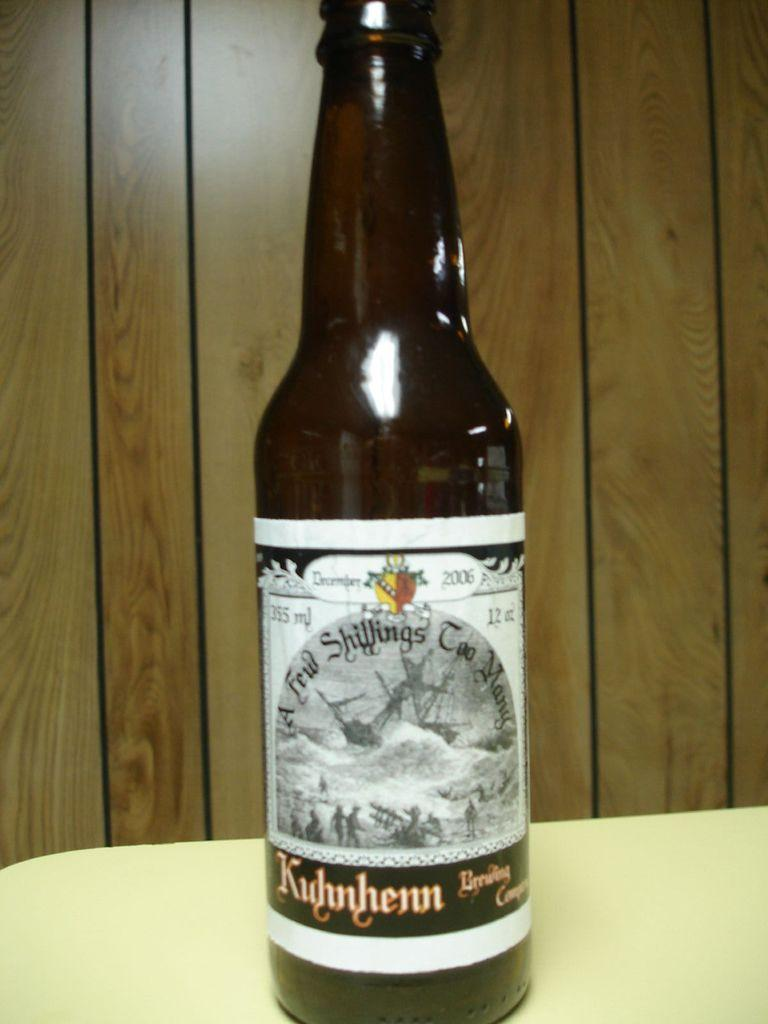<image>
Summarize the visual content of the image. bottle of december 2006 kuhnhenn on a table against wood paneling 